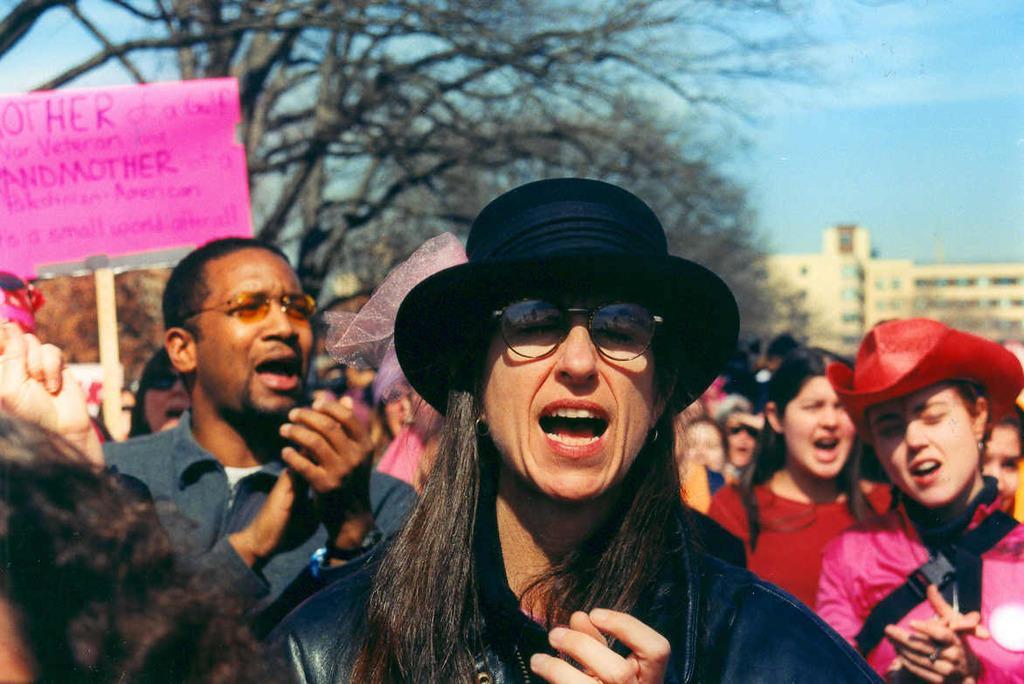Describe this image in one or two sentences. In this image there are few people in which one of them holds a board with some written text, there are trees, a building and the sky. 